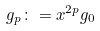Convert formula to latex. <formula><loc_0><loc_0><loc_500><loc_500>g _ { p } \colon = x ^ { 2 p } g _ { 0 }</formula> 